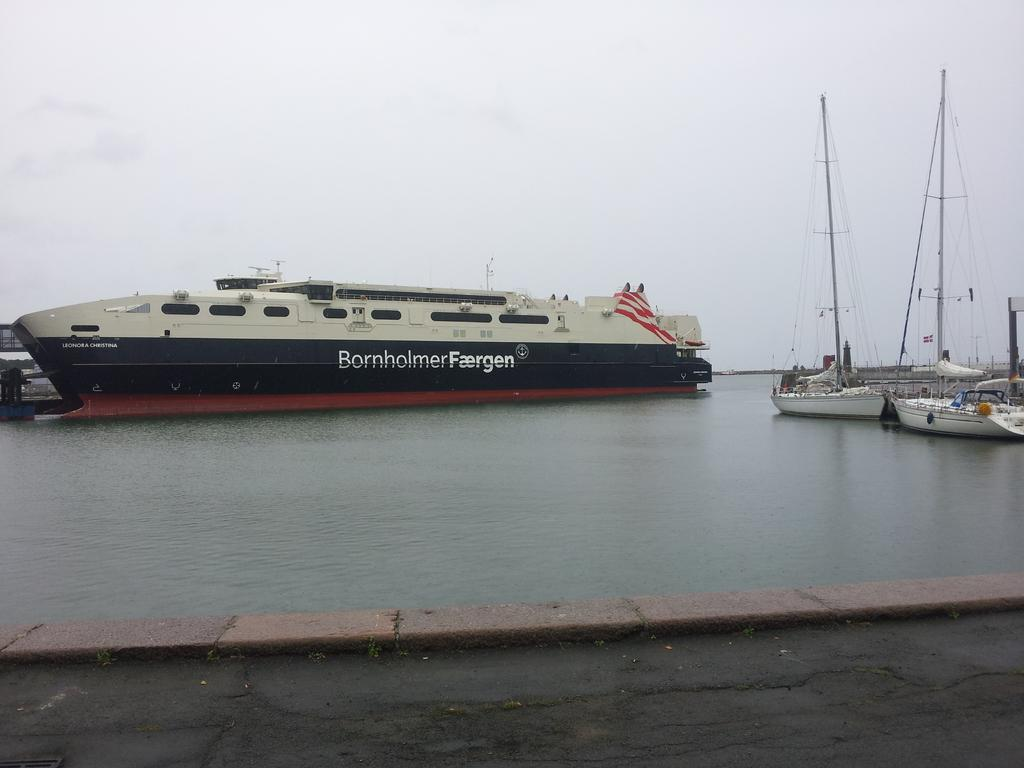<image>
Render a clear and concise summary of the photo. the word Bornholmer that is on a ship 